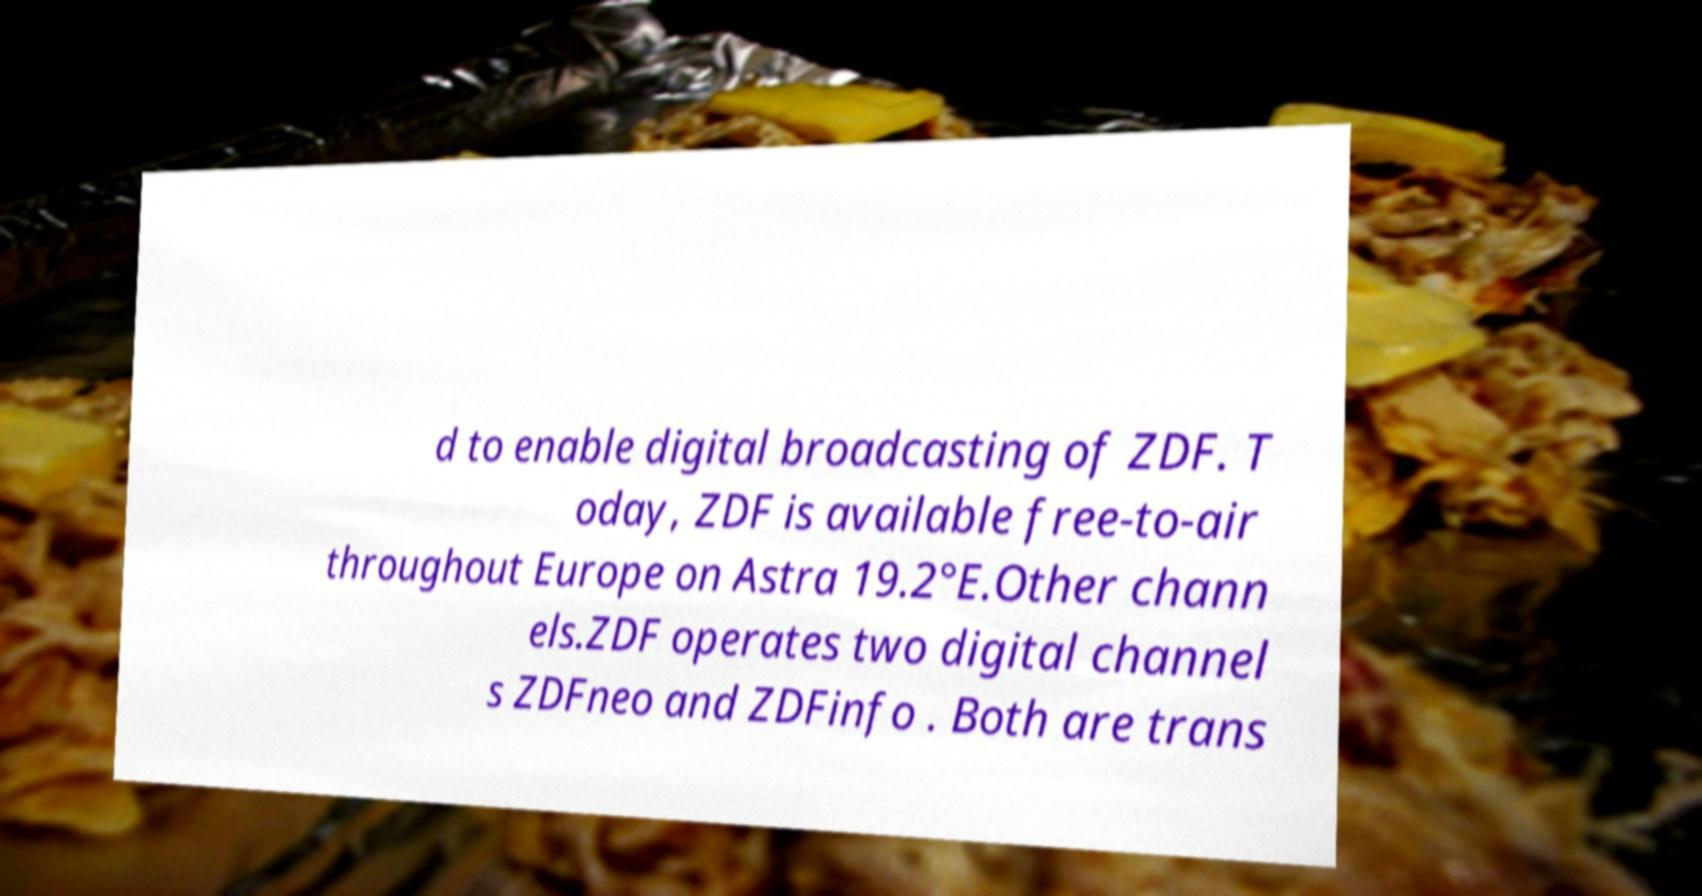Please identify and transcribe the text found in this image. d to enable digital broadcasting of ZDF. T oday, ZDF is available free-to-air throughout Europe on Astra 19.2°E.Other chann els.ZDF operates two digital channel s ZDFneo and ZDFinfo . Both are trans 